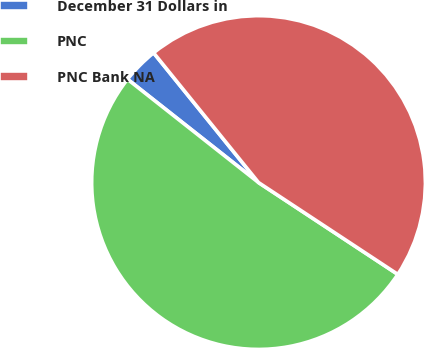Convert chart. <chart><loc_0><loc_0><loc_500><loc_500><pie_chart><fcel>December 31 Dollars in<fcel>PNC<fcel>PNC Bank NA<nl><fcel>3.55%<fcel>51.35%<fcel>45.1%<nl></chart> 